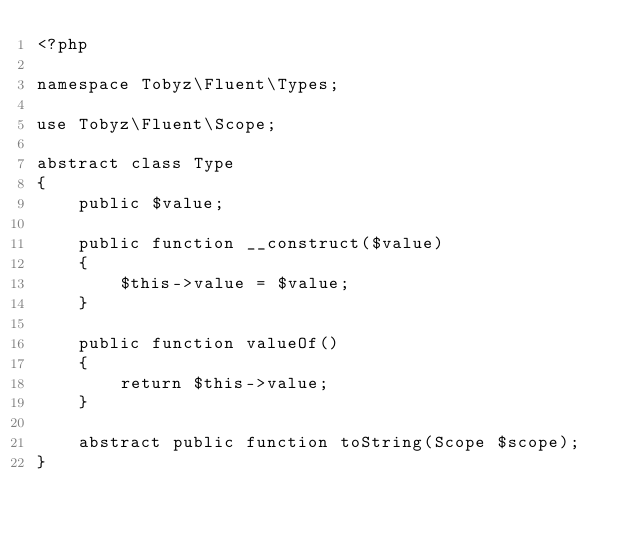<code> <loc_0><loc_0><loc_500><loc_500><_PHP_><?php

namespace Tobyz\Fluent\Types;

use Tobyz\Fluent\Scope;

abstract class Type
{
    public $value;

    public function __construct($value)
    {
        $this->value = $value;
    }

    public function valueOf()
    {
        return $this->value;
    }

    abstract public function toString(Scope $scope);
}

</code> 